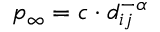<formula> <loc_0><loc_0><loc_500><loc_500>p _ { \infty } = c \cdot d _ { i j } ^ { - \alpha }</formula> 